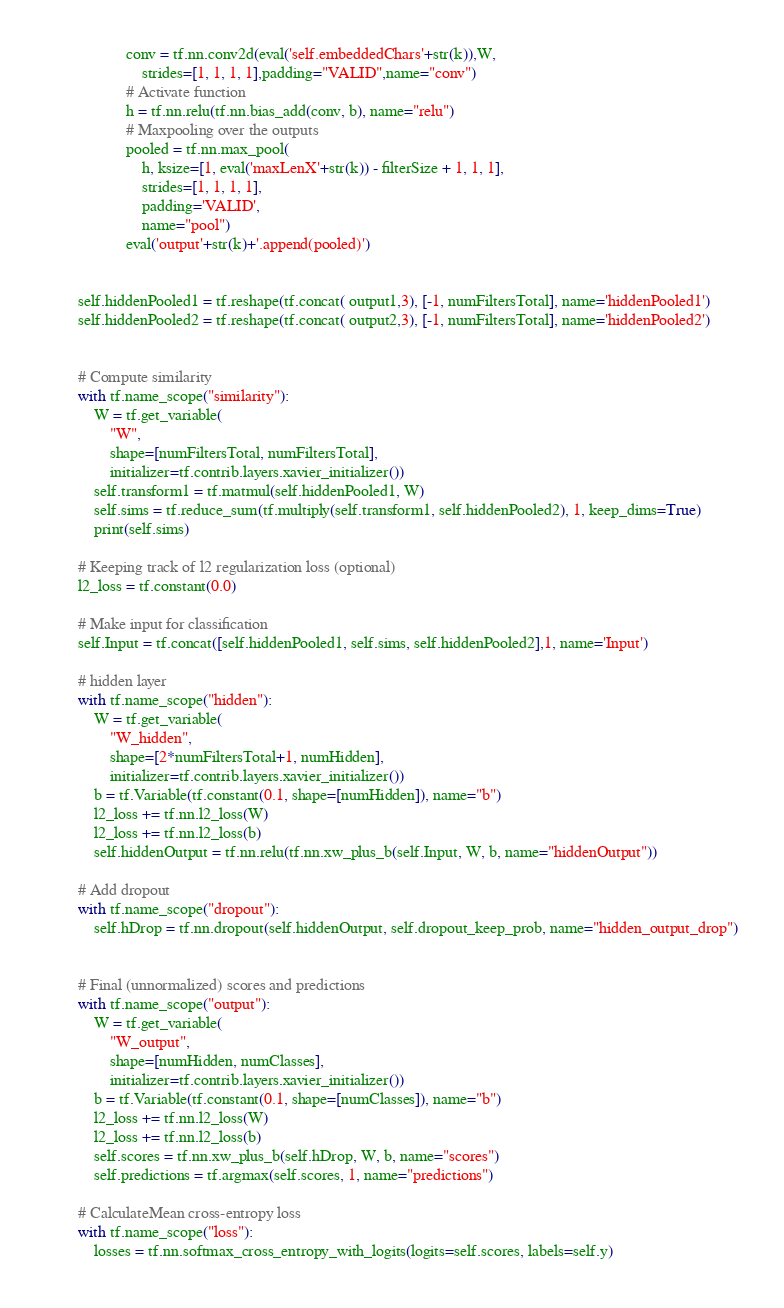Convert code to text. <code><loc_0><loc_0><loc_500><loc_500><_Python_>                    conv = tf.nn.conv2d(eval('self.embeddedChars'+str(k)),W,
                        strides=[1, 1, 1, 1],padding="VALID",name="conv")
                    # Activate function
                    h = tf.nn.relu(tf.nn.bias_add(conv, b), name="relu")
                    # Maxpooling over the outputs
                    pooled = tf.nn.max_pool(
                        h, ksize=[1, eval('maxLenX'+str(k)) - filterSize + 1, 1, 1],
                        strides=[1, 1, 1, 1],
                        padding='VALID',
                        name="pool")
                    eval('output'+str(k)+'.append(pooled)') 


        self.hiddenPooled1 = tf.reshape(tf.concat( output1,3), [-1, numFiltersTotal], name='hiddenPooled1')
        self.hiddenPooled2 = tf.reshape(tf.concat( output2,3), [-1, numFiltersTotal], name='hiddenPooled2')
        

        # Compute similarity
        with tf.name_scope("similarity"):
            W = tf.get_variable(
                "W",
                shape=[numFiltersTotal, numFiltersTotal],
                initializer=tf.contrib.layers.xavier_initializer())
            self.transform1 = tf.matmul(self.hiddenPooled1, W)
            self.sims = tf.reduce_sum(tf.multiply(self.transform1, self.hiddenPooled2), 1, keep_dims=True)
            print(self.sims)

        # Keeping track of l2 regularization loss (optional)
        l2_loss = tf.constant(0.0)

        # Make input for classification
        self.Input = tf.concat([self.hiddenPooled1, self.sims, self.hiddenPooled2],1, name='Input')

        # hidden layer
        with tf.name_scope("hidden"):
            W = tf.get_variable(
                "W_hidden",
                shape=[2*numFiltersTotal+1, numHidden],
                initializer=tf.contrib.layers.xavier_initializer())
            b = tf.Variable(tf.constant(0.1, shape=[numHidden]), name="b")
            l2_loss += tf.nn.l2_loss(W)
            l2_loss += tf.nn.l2_loss(b)
            self.hiddenOutput = tf.nn.relu(tf.nn.xw_plus_b(self.Input, W, b, name="hiddenOutput"))

        # Add dropout
        with tf.name_scope("dropout"):
            self.hDrop = tf.nn.dropout(self.hiddenOutput, self.dropout_keep_prob, name="hidden_output_drop")


        # Final (unnormalized) scores and predictions
        with tf.name_scope("output"):
            W = tf.get_variable(
                "W_output",
                shape=[numHidden, numClasses],
                initializer=tf.contrib.layers.xavier_initializer())
            b = tf.Variable(tf.constant(0.1, shape=[numClasses]), name="b")
            l2_loss += tf.nn.l2_loss(W)
            l2_loss += tf.nn.l2_loss(b)
            self.scores = tf.nn.xw_plus_b(self.hDrop, W, b, name="scores")
            self.predictions = tf.argmax(self.scores, 1, name="predictions")

        # CalculateMean cross-entropy loss
        with tf.name_scope("loss"):
            losses = tf.nn.softmax_cross_entropy_with_logits(logits=self.scores, labels=self.y)</code> 